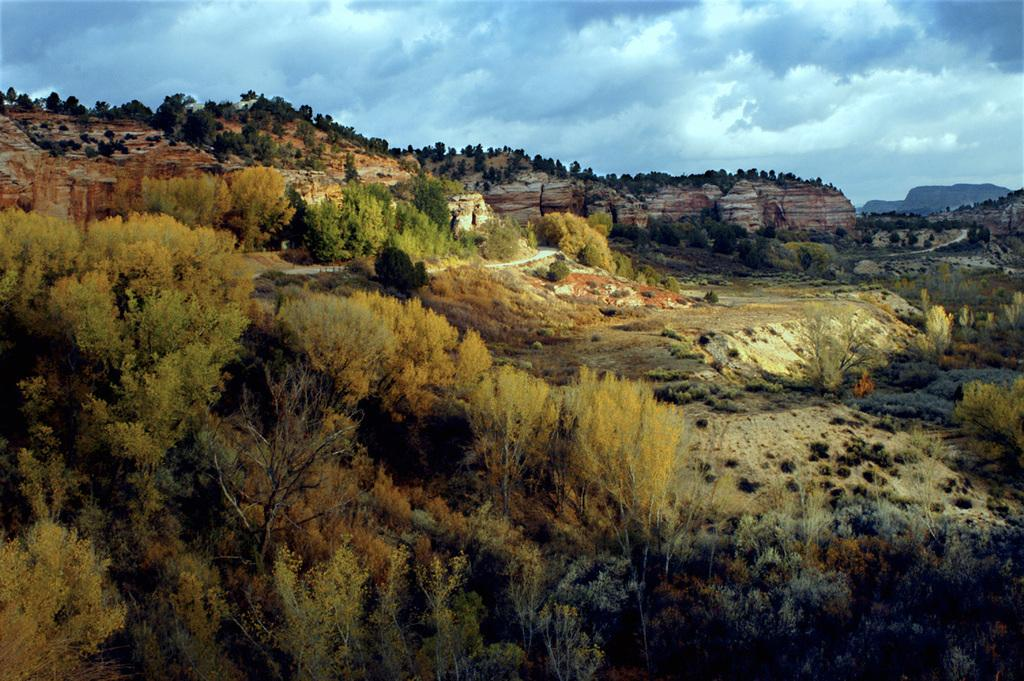Where was the picture taken? The picture was clicked outside the city. What type of vegetation can be seen in the image? There are trees and plants in the image. What geographical feature is visible in the image? There are hills in the image. What can be seen in the background of the image? The sky is visible in the background of the image. What is the condition of the sky in the image? The sky is full of clouds. What type of ship can be seen sailing on the grass in the image? There is no ship present in the image, and the grass is not a body of water for a ship to sail on. 